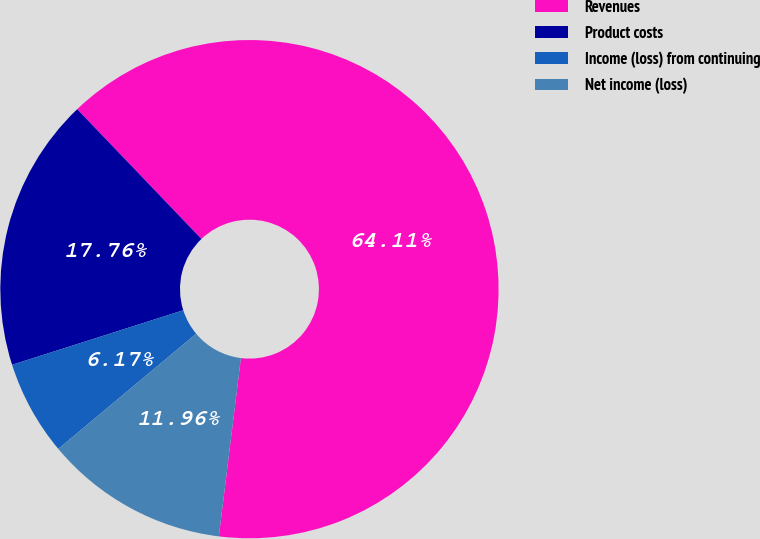Convert chart to OTSL. <chart><loc_0><loc_0><loc_500><loc_500><pie_chart><fcel>Revenues<fcel>Product costs<fcel>Income (loss) from continuing<fcel>Net income (loss)<nl><fcel>64.12%<fcel>17.76%<fcel>6.17%<fcel>11.96%<nl></chart> 